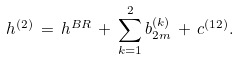Convert formula to latex. <formula><loc_0><loc_0><loc_500><loc_500>h ^ { ( 2 ) } \, = \, h ^ { B R } \, + \, \sum _ { k = 1 } ^ { 2 } b _ { 2 m } ^ { ( k ) } \, + \, c ^ { ( 1 2 ) } .</formula> 